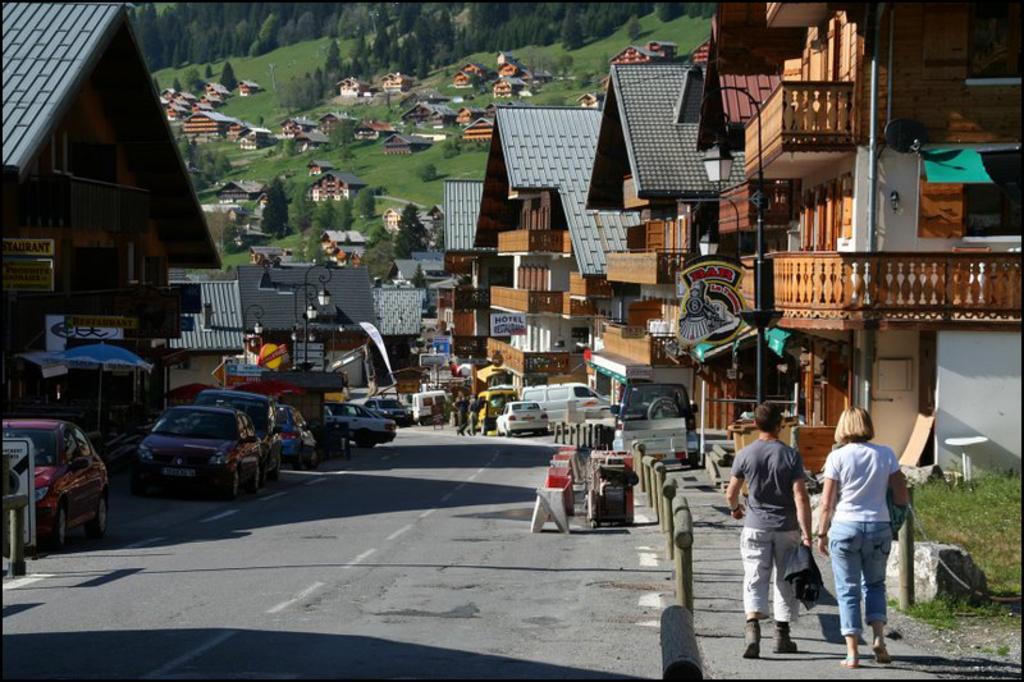Could you give a brief overview of what you see in this image? In this picture I can see few vehicles are on the road, side of the road few people are walking, around there are some houses and trees. 